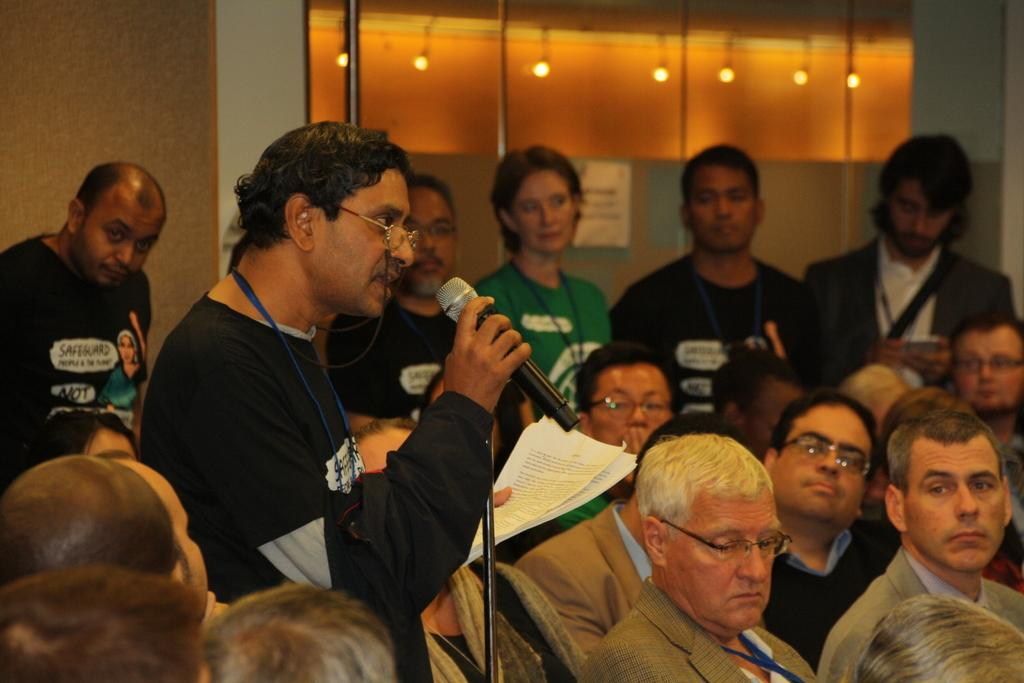What is the person in the image holding? The person is holding a microphone in the image. What is the person with the microphone doing? The person is speaking. Are there other people in the image besides the speaker? Yes, there are people in the image. How are the other people in the image reacting to the speaker? The people are paying attention to the speaker. Can you hear the tiger singing in the background of the image? There is no tiger or singing present in the image. 